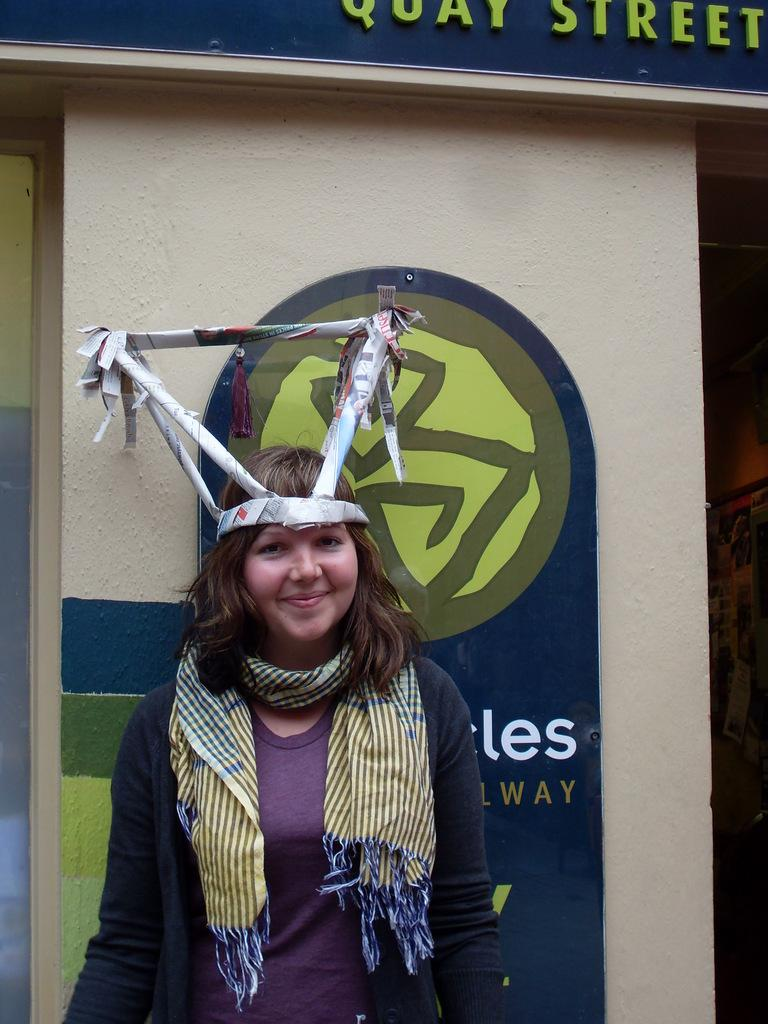Who is the main subject in the image? There is a lady in the center of the image. What is the lady wearing around her neck? The lady is wearing a scarf. What is unique about the lady's headwear? There is a paper craft on the lady's head. What can be seen in the background of the image? There is a wall and boards visible in the background of the image. What type of sugar is being used to fill the lady's mouth in the image? There is no sugar or mouth visible in the image; it features a lady with a paper craft on her head. What is the lead content of the paper craft on the lady's head? The lead content cannot be determined from the image, as it does not provide information about the materials used in the paper craft. 